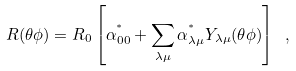<formula> <loc_0><loc_0><loc_500><loc_500>R ( \theta \phi ) = R _ { 0 } \left [ \alpha _ { 0 0 } ^ { ^ { * } } + \sum _ { \lambda \mu } \alpha _ { \lambda \mu } ^ { ^ { * } } Y _ { \lambda \mu } ( \theta \phi ) \right ] \ ,</formula> 